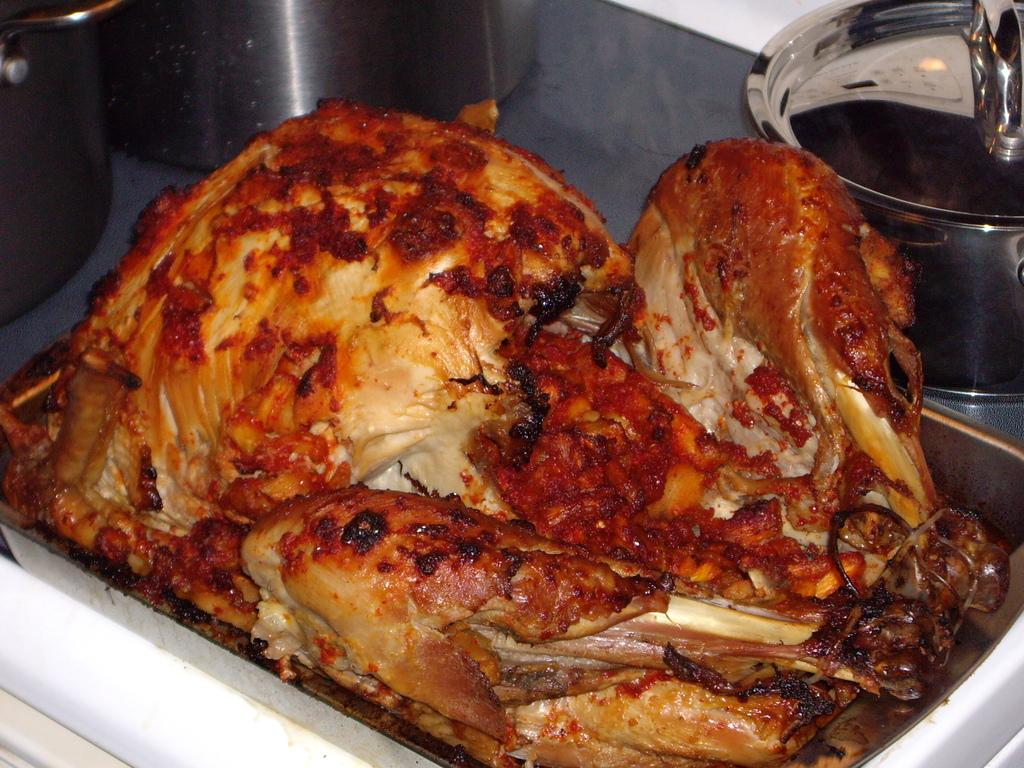What is on the tray in the image? There is food on a tray in the image. Can you describe anything visible in the background of the image? There are vessels visible in the background of the image. What is the belief system of the food on the tray in the image? The food on the tray does not have a belief system, as it is an inanimate object. 